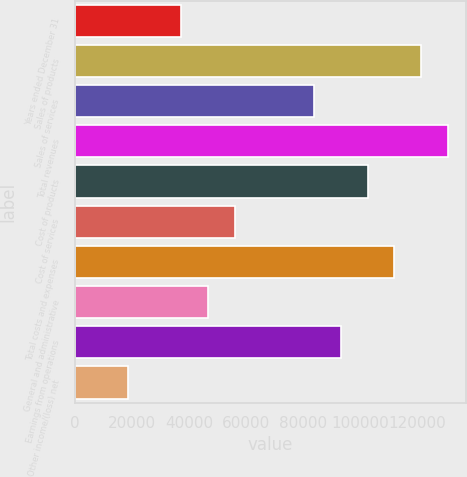Convert chart to OTSL. <chart><loc_0><loc_0><loc_500><loc_500><bar_chart><fcel>Years ended December 31<fcel>Sales of products<fcel>Sales of services<fcel>Total revenues<fcel>Cost of products<fcel>Cost of services<fcel>Total costs and expenses<fcel>General and administrative<fcel>Earnings from operations<fcel>Other income/(loss) net<nl><fcel>37364.9<fcel>121406<fcel>84054.2<fcel>130743<fcel>102730<fcel>56040.6<fcel>112068<fcel>46702.7<fcel>93392<fcel>18689.2<nl></chart> 